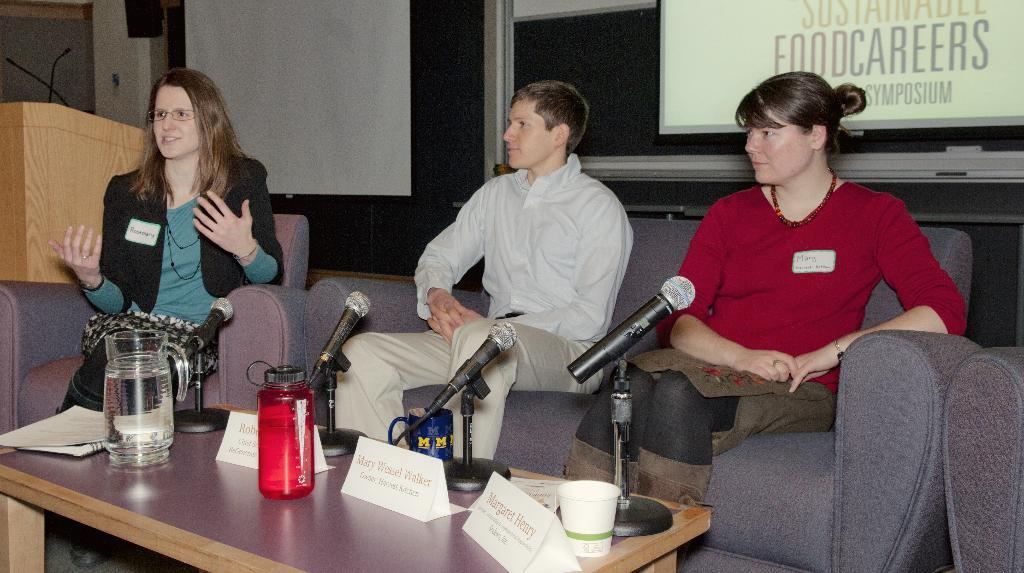How many people are sitting on the couch in the image? There are three persons sitting on the couch in the image. What object can be seen on the table in the image? There is a microphone, a cup, a bottle, and a jar on the table in the image. What is the purpose of the microphone on the table? The microphone on the table is likely used for recording or amplifying sound. What is visible at the back side of the image? There is a screen visible at the back side of the image. Can you tell me how many spades are being used by the persons sitting on the couch? There is no mention of spades in the image, so it cannot be determined if any are being used. Is there a dog visible in the image? No, there is no dog present in the image. 